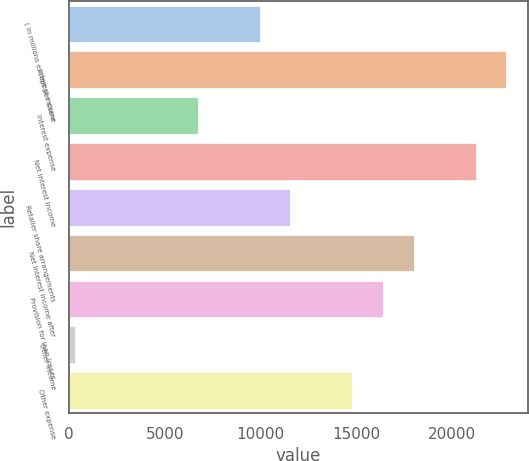Convert chart. <chart><loc_0><loc_0><loc_500><loc_500><bar_chart><fcel>( in millions except per share<fcel>Interest income<fcel>Interest expense<fcel>Net interest income<fcel>Retailer share arrangements<fcel>Net interest income after<fcel>Provision for loan losses<fcel>Other income<fcel>Other expense<nl><fcel>9959.4<fcel>22854.6<fcel>6735.6<fcel>21242.7<fcel>11571.3<fcel>18018.9<fcel>16407<fcel>288<fcel>14795.1<nl></chart> 